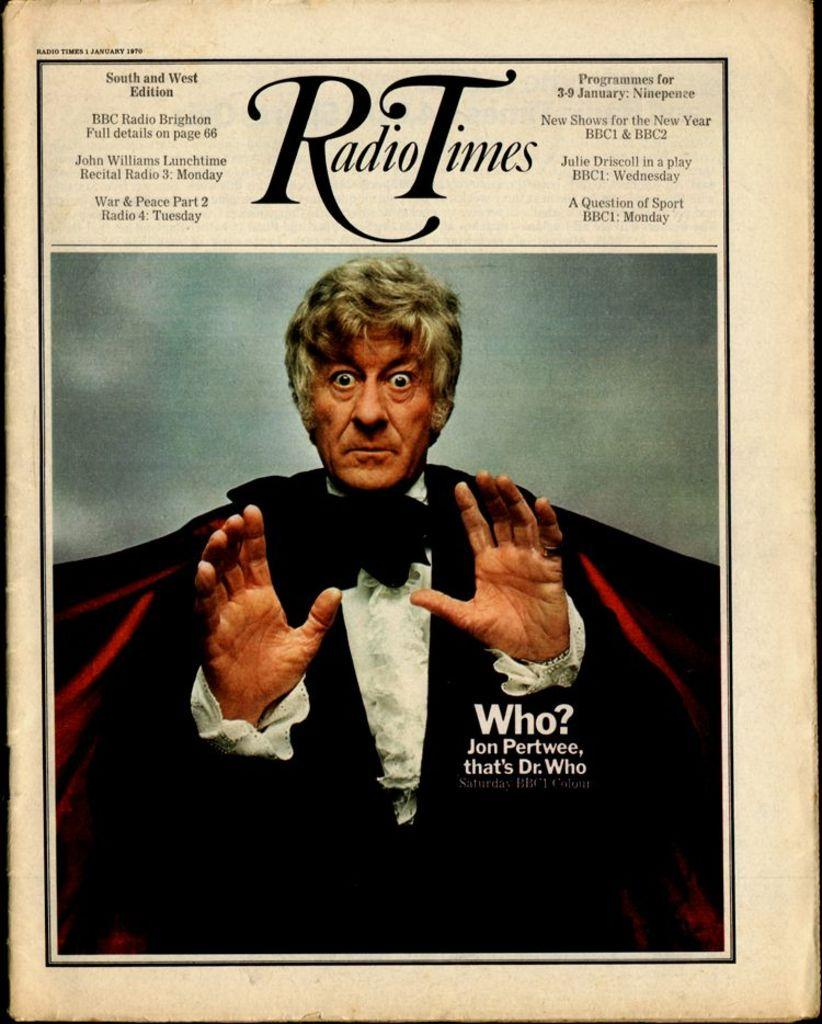What type of image is being described? The image is a poster. Who is depicted in the poster? There is a man in the poster. What is the man doing in the poster? The man is showing his hands. What else can be found on the poster besides the man? There is text on the poster. What type of rhythm does the man's aunt have in the poster? There is no mention of an aunt or rhythm in the poster; it only features a man showing his hands and text. 